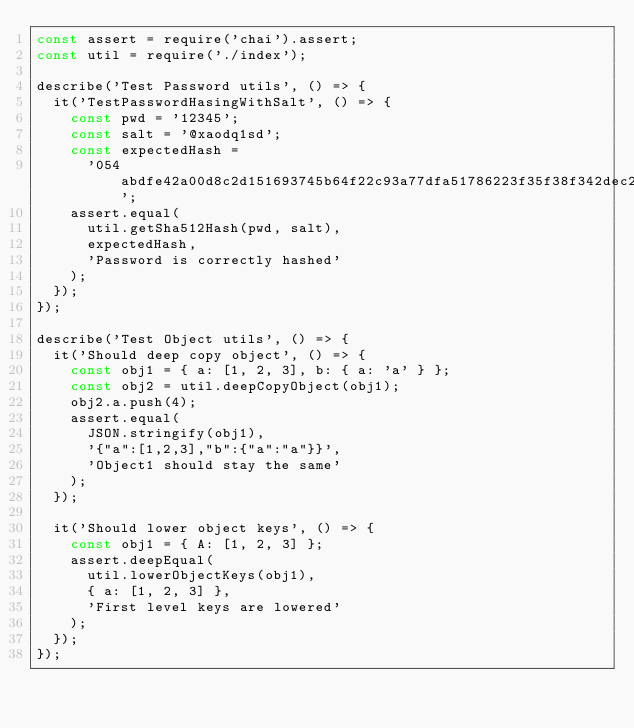<code> <loc_0><loc_0><loc_500><loc_500><_JavaScript_>const assert = require('chai').assert;
const util = require('./index');

describe('Test Password utils', () => {
  it('TestPasswordHasingWithSalt', () => {
    const pwd = '12345';
    const salt = '@xaodq1sd';
    const expectedHash =
      '054abdfe42a00d8c2d151693745b64f22c93a77dfa51786223f35f38f342dec24e4e4056e0e2975f406ed21ab2562ef951dbcc37faca3d5a5add81c5ca81b58e';
    assert.equal(
      util.getSha512Hash(pwd, salt),
      expectedHash,
      'Password is correctly hashed'
    );
  });
});

describe('Test Object utils', () => {
  it('Should deep copy object', () => {
    const obj1 = { a: [1, 2, 3], b: { a: 'a' } };
    const obj2 = util.deepCopyObject(obj1);
    obj2.a.push(4);
    assert.equal(
      JSON.stringify(obj1),
      '{"a":[1,2,3],"b":{"a":"a"}}',
      'Object1 should stay the same'
    );
  });

  it('Should lower object keys', () => {
    const obj1 = { A: [1, 2, 3] };
    assert.deepEqual(
      util.lowerObjectKeys(obj1),
      { a: [1, 2, 3] },
      'First level keys are lowered'
    );
  });
});
</code> 